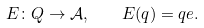Convert formula to latex. <formula><loc_0><loc_0><loc_500><loc_500>E \colon Q \to \mathcal { A } , \quad E ( q ) = q e .</formula> 